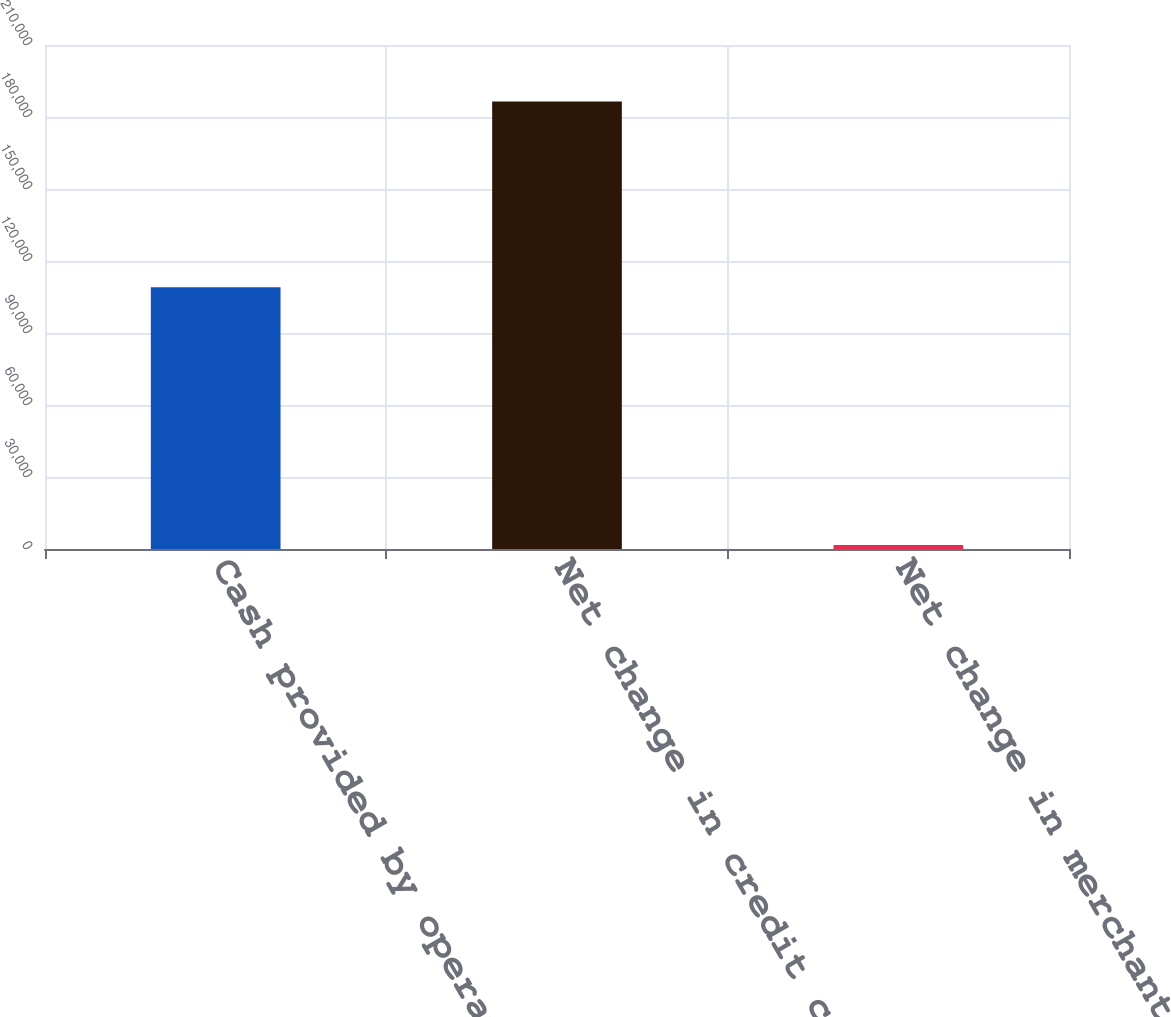<chart> <loc_0><loc_0><loc_500><loc_500><bar_chart><fcel>Cash provided by operating<fcel>Net change in credit card<fcel>Net change in merchant<nl><fcel>109081<fcel>186419<fcel>1637<nl></chart> 